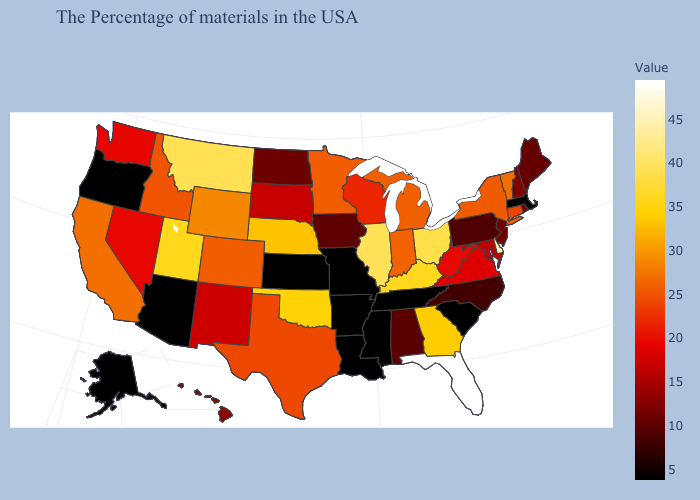Among the states that border South Dakota , which have the highest value?
Quick response, please. Montana. Is the legend a continuous bar?
Give a very brief answer. Yes. Does Maine have the lowest value in the Northeast?
Keep it brief. No. Does Florida have the highest value in the USA?
Short answer required. Yes. Among the states that border Maine , which have the highest value?
Concise answer only. New Hampshire. Is the legend a continuous bar?
Be succinct. Yes. 